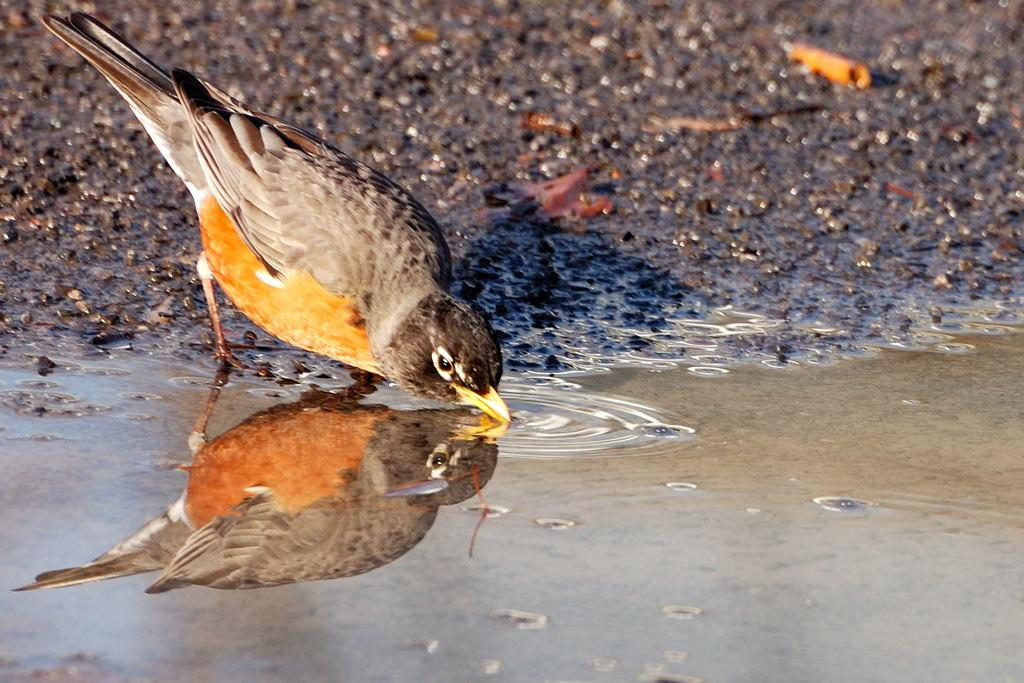What type of animal can be seen in the image? There is a bird in the image. What is the bird doing in the image? The bird is drinking water. What colors can be observed on the bird in the image? The bird is brown and black in color. What type of wax can be seen on the bird's toe in the image? There is no wax or toe present on the bird in the image; it is simply drinking water. 